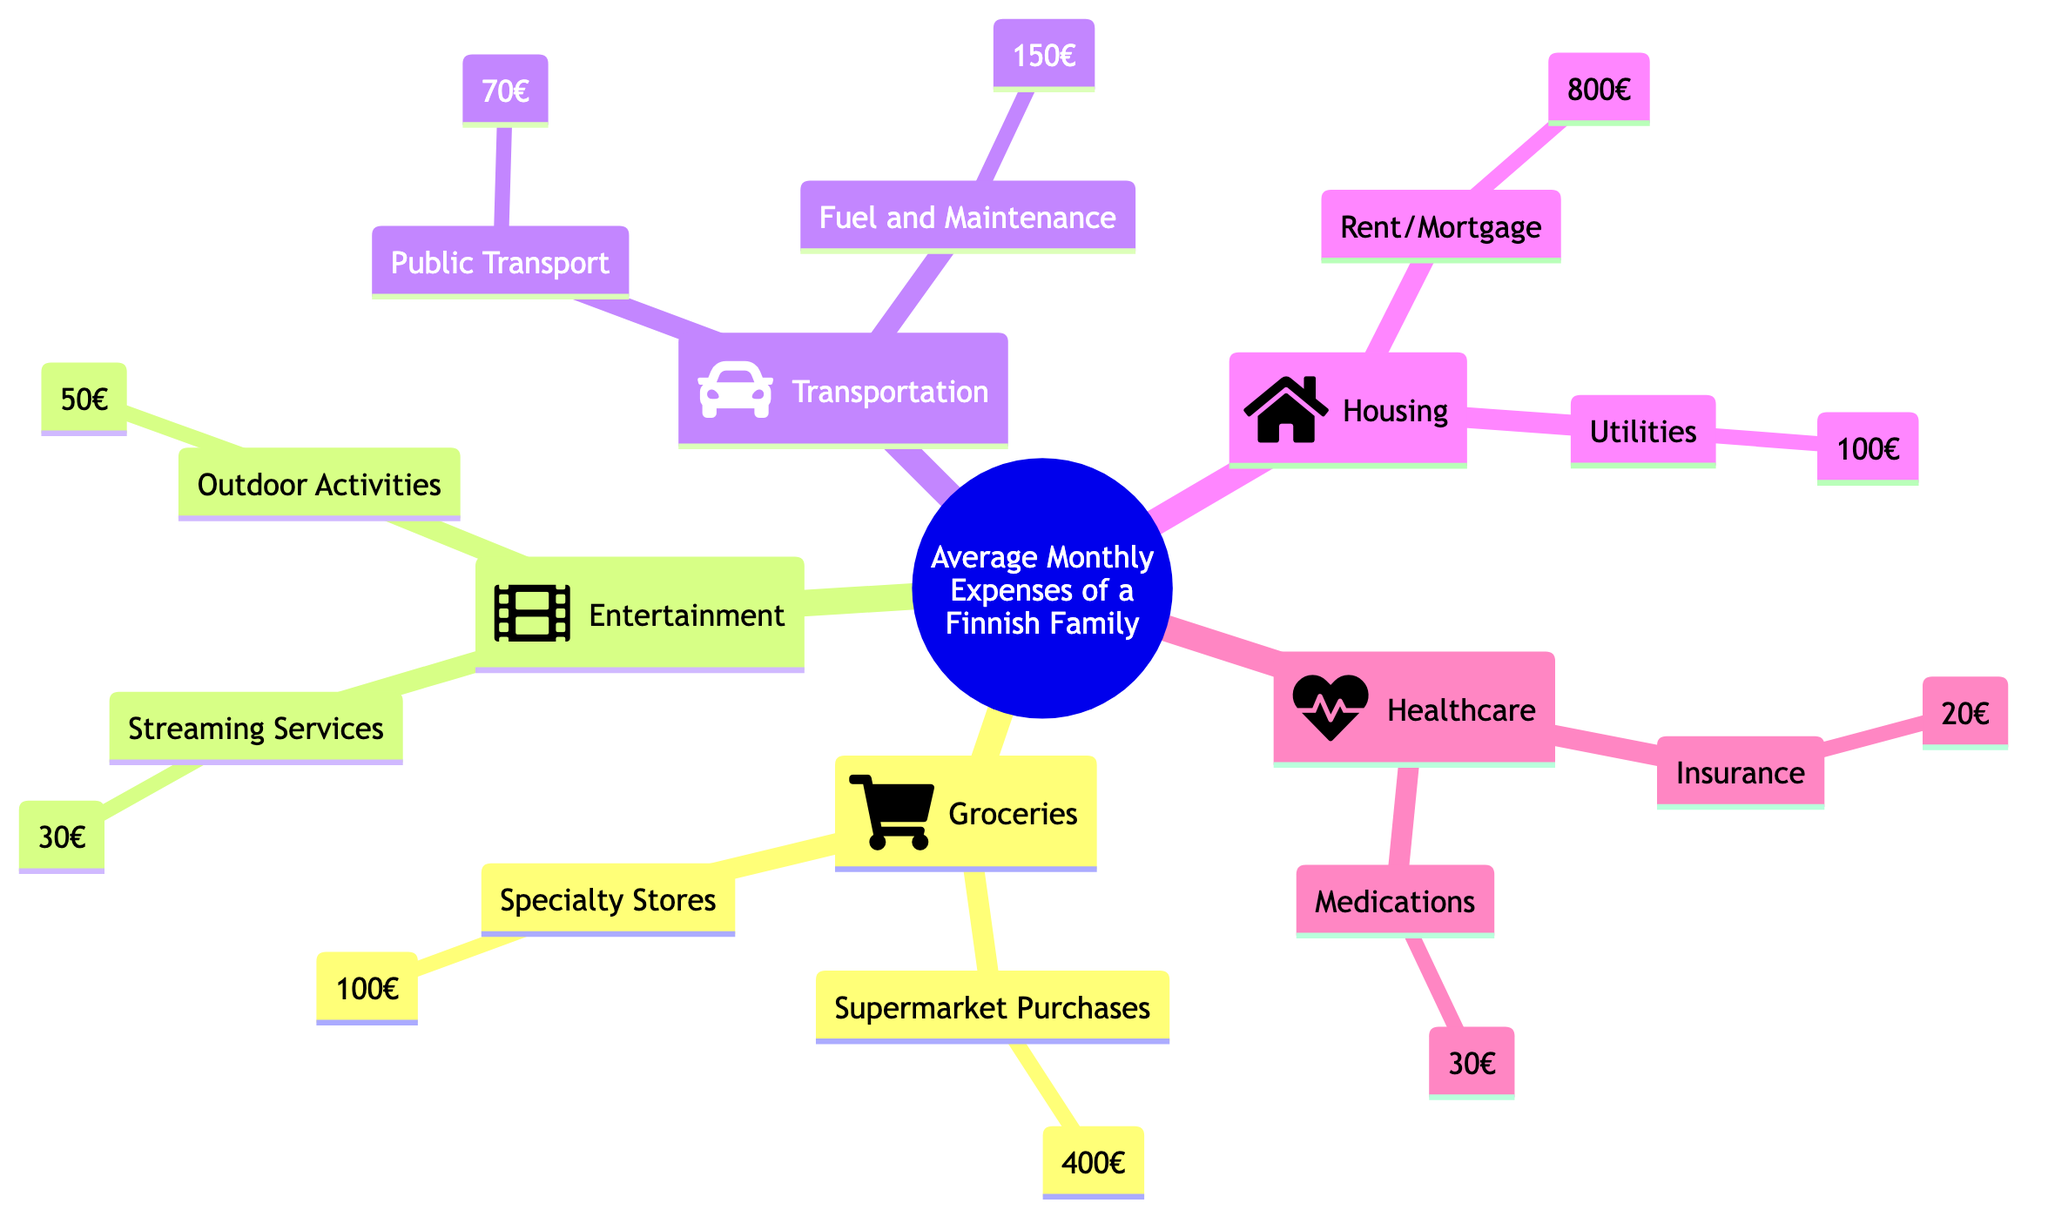What is the monthly expense for Groceries? The diagram indicates two categories under Groceries: Supermarket Purchases costing 400€ and Specialty Stores costing 100€. Adding these amounts gives a total of 400€ + 100€ = 500€.
Answer: 500€ How much does a Finnish family spend on Housing? Under the Housing section, two values are presented: Rent/Mortgage costs 800€ and Utilities cost 100€. Summing these amounts results in 800€ + 100€ = 900€.
Answer: 900€ What is the expense for Transportation? The Transportation category contains two components: Public Transport at 70€ and Fuel and Maintenance at 150€. Combining these amounts gives 70€ + 150€ = 220€.
Answer: 220€ Which expense category has the highest total? From the calculations, Housing is 900€, Groceries is 500€, Entertainment is 80€, and Transportation is 220€. The highest value among these is Housing at 900€.
Answer: Housing What are the total monthly expenses for Healthcare? The Healthcare section lists two costs: Insurance at 20€ and Medications at 30€. The total expense combines these amounts: 20€ + 30€ = 50€.
Answer: 50€ How much is spent on Streaming Services compared to Outdoor Activities? The amount spent on Streaming Services is 30€, while Outdoor Activities cost 50€. Comparing these figures reveals that the Outdoor Activities expense is higher than Streaming Services.
Answer: Higher What is the total expenditure for Entertainment? Two contributions to the Entertainment category are noted: Streaming Services costing 30€ and Outdoor Activities costing 50€. The total for this category is 30€ + 50€ = 80€.
Answer: 80€ What is the difference in expenses between Fuel and Maintenance and Utilities? Fuel and Maintenance costs 150€, and Utilities in the Housing category costs 100€. The difference is calculated by subtracting Utilities from Fuel and Maintenance, which is 150€ - 100€ = 50€.
Answer: 50€ Which category has fewer components, Entertainment or Transportation? The Transportation category consists of two components (Public Transport and Fuel and Maintenance), while the Entertainment category also consists of two components (Streaming Services and Outdoor Activities). Both categories have the same number of components.
Answer: Same 